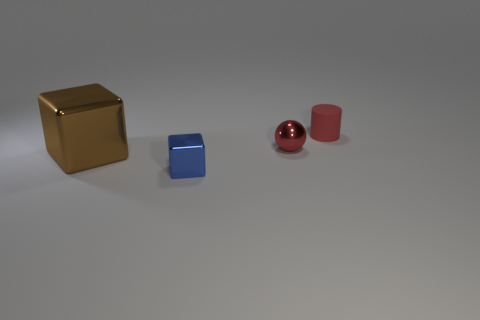Subtract all balls. How many objects are left? 3 Add 3 tiny metal objects. How many objects exist? 7 Subtract 1 blocks. How many blocks are left? 1 Subtract all red balls. How many green blocks are left? 0 Add 3 tiny blue shiny cubes. How many tiny blue shiny cubes are left? 4 Add 3 small cyan matte balls. How many small cyan matte balls exist? 3 Subtract 0 gray spheres. How many objects are left? 4 Subtract all blue blocks. Subtract all cyan spheres. How many blocks are left? 1 Subtract all large purple rubber cylinders. Subtract all small objects. How many objects are left? 1 